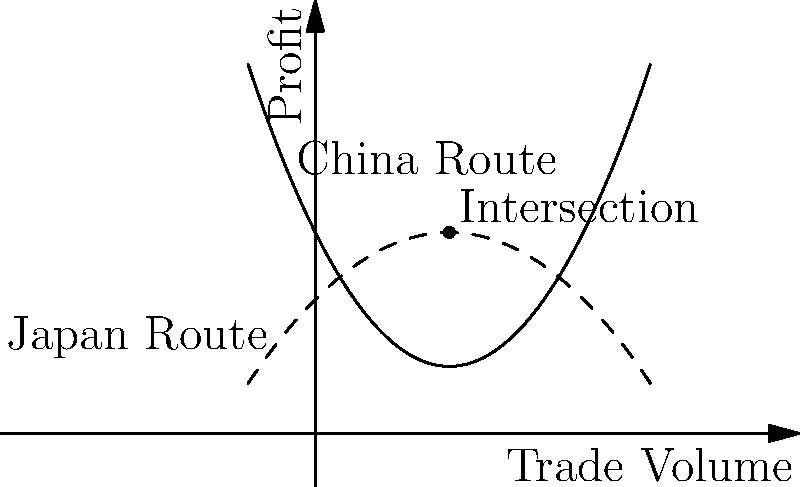In the graph above, two polynomial curves represent the profit functions for trade routes between ancient China and Japan. The solid curve represents the China route, while the dashed curve represents the Japan route. At what trade volume do these routes achieve equal profitability, and what is the corresponding profit? Express your answer as an ordered pair $(x,y)$, where $x$ represents the trade volume and $y$ represents the profit. To solve this problem, we need to follow these steps:

1) Identify the equations of the two curves:
   China route (solid): $f(x) = 0.5x^2 - 2x + 3$
   Japan route (dashed): $g(x) = -0.25x^2 + x + 2$

2) Find the intersection point by equating these functions:
   $0.5x^2 - 2x + 3 = -0.25x^2 + x + 2$

3) Rearrange the equation:
   $0.75x^2 - 3x + 1 = 0$

4) This is a quadratic equation. We can solve it using the quadratic formula:
   $x = \frac{-b \pm \sqrt{b^2 - 4ac}}{2a}$

   Where $a = 0.75$, $b = -3$, and $c = 1$

5) Plugging in these values:
   $x = \frac{3 \pm \sqrt{9 - 3}}{1.5} = \frac{3 \pm \sqrt{6}}{1.5}$

6) Simplifying:
   $x = 2$ or $x = \frac{2}{3}$

7) The graph shows the intersection at $x = 2$, so we'll use this value.

8) To find the y-coordinate (profit), we can substitute $x = 2$ into either of the original equations:
   $f(2) = 0.5(2)^2 - 2(2) + 3 = 2 - 4 + 3 = 1$
   $g(2) = -0.25(2)^2 + 2 + 2 = -1 + 2 + 2 = 3$

Therefore, the intersection point is $(2, 3)$.
Answer: $(2,3)$ 